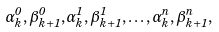<formula> <loc_0><loc_0><loc_500><loc_500>\alpha ^ { 0 } _ { k } , \beta ^ { 0 } _ { k + 1 } , \alpha ^ { 1 } _ { k } , \beta ^ { 1 } _ { k + 1 } , \dots , \alpha ^ { n } _ { k } , \beta ^ { n } _ { k + 1 } ,</formula> 